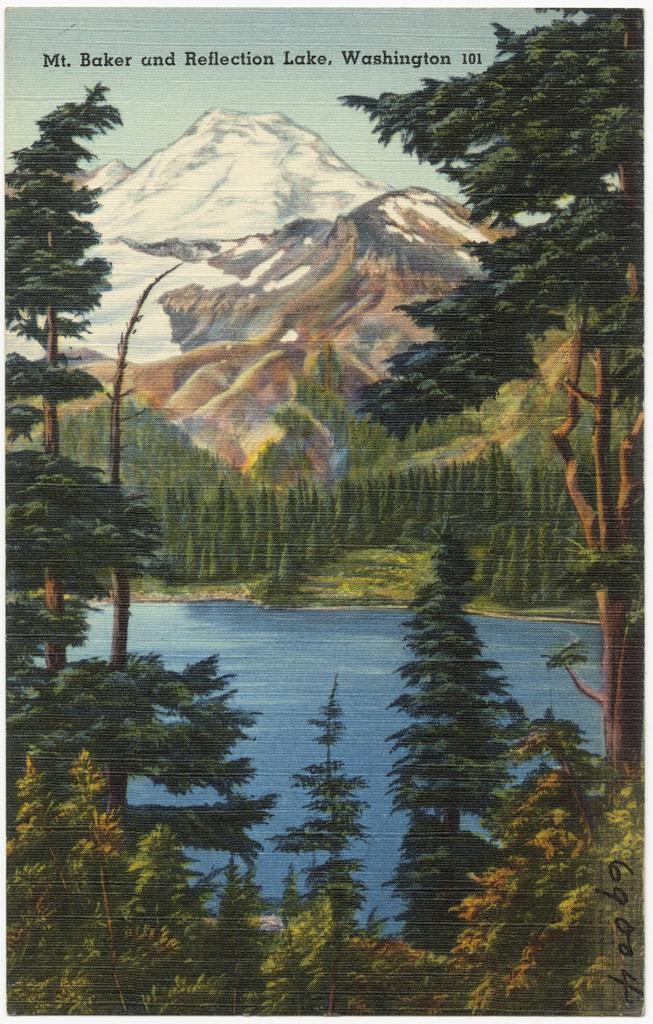Describe this image in one or two sentences. This is a painting and here we can see mountains, trees and at the bottom, there is water. 